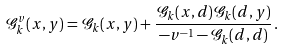Convert formula to latex. <formula><loc_0><loc_0><loc_500><loc_500>\mathcal { G } _ { k } ^ { v } ( x , y ) = \mathcal { G } _ { k } ( x , y ) + \frac { \mathcal { G } _ { k } ( x , d ) \mathcal { G } _ { k } ( d , y ) } { - v ^ { - 1 } - \mathcal { G } _ { k } ( d , d ) } \, .</formula> 